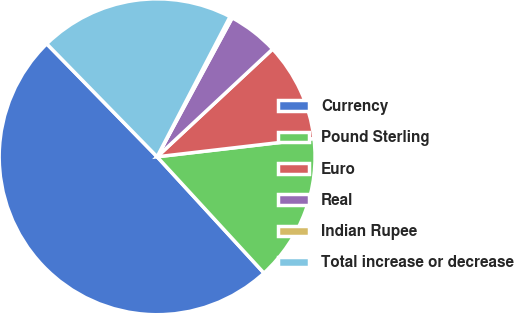Convert chart to OTSL. <chart><loc_0><loc_0><loc_500><loc_500><pie_chart><fcel>Currency<fcel>Pound Sterling<fcel>Euro<fcel>Real<fcel>Indian Rupee<fcel>Total increase or decrease<nl><fcel>49.51%<fcel>15.02%<fcel>10.1%<fcel>5.17%<fcel>0.25%<fcel>19.95%<nl></chart> 